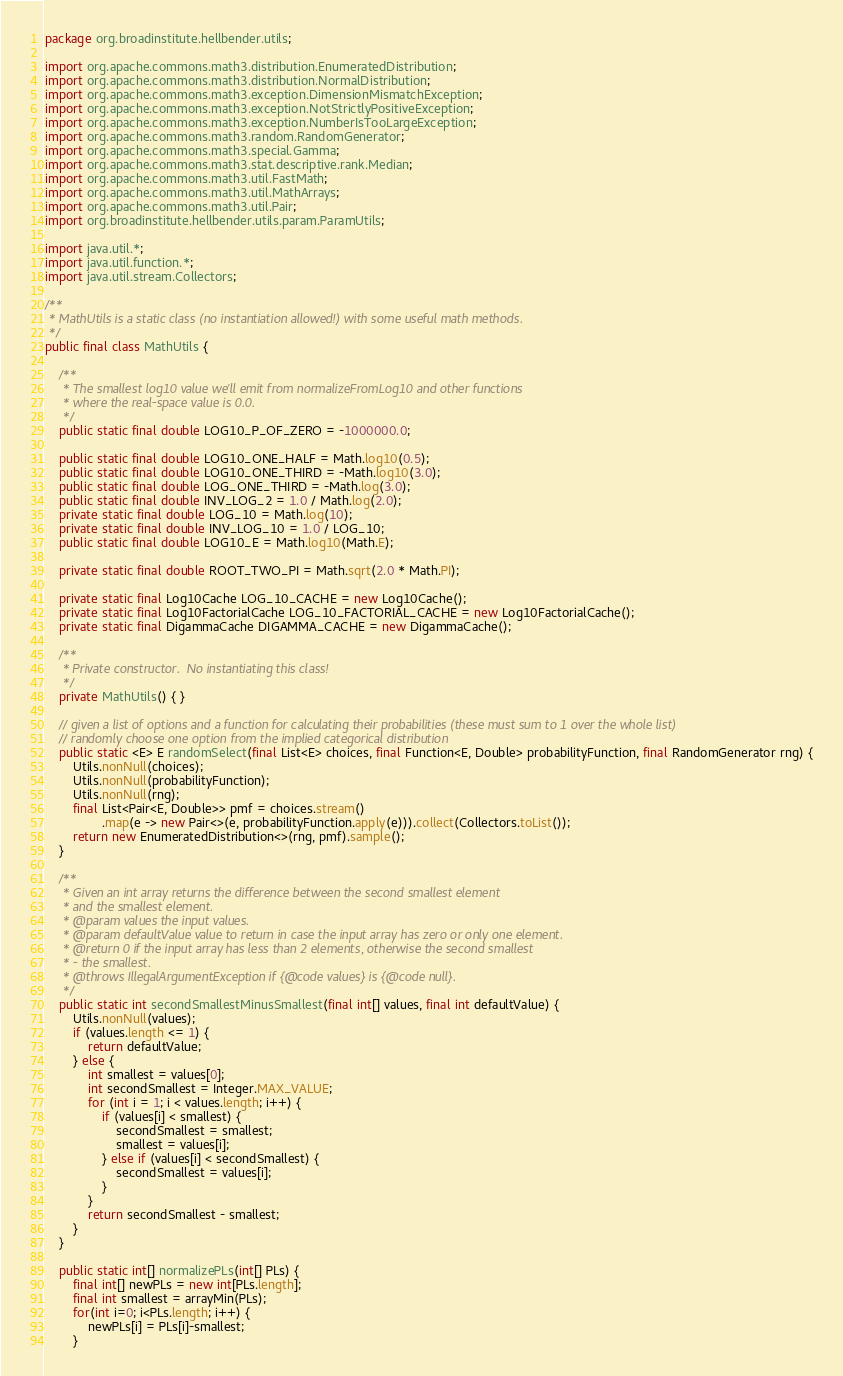<code> <loc_0><loc_0><loc_500><loc_500><_Java_>package org.broadinstitute.hellbender.utils;

import org.apache.commons.math3.distribution.EnumeratedDistribution;
import org.apache.commons.math3.distribution.NormalDistribution;
import org.apache.commons.math3.exception.DimensionMismatchException;
import org.apache.commons.math3.exception.NotStrictlyPositiveException;
import org.apache.commons.math3.exception.NumberIsTooLargeException;
import org.apache.commons.math3.random.RandomGenerator;
import org.apache.commons.math3.special.Gamma;
import org.apache.commons.math3.stat.descriptive.rank.Median;
import org.apache.commons.math3.util.FastMath;
import org.apache.commons.math3.util.MathArrays;
import org.apache.commons.math3.util.Pair;
import org.broadinstitute.hellbender.utils.param.ParamUtils;

import java.util.*;
import java.util.function.*;
import java.util.stream.Collectors;

/**
 * MathUtils is a static class (no instantiation allowed!) with some useful math methods.
 */
public final class MathUtils {

    /**
     * The smallest log10 value we'll emit from normalizeFromLog10 and other functions
     * where the real-space value is 0.0.
     */
    public static final double LOG10_P_OF_ZERO = -1000000.0;

    public static final double LOG10_ONE_HALF = Math.log10(0.5);
    public static final double LOG10_ONE_THIRD = -Math.log10(3.0);
    public static final double LOG_ONE_THIRD = -Math.log(3.0);
    public static final double INV_LOG_2 = 1.0 / Math.log(2.0);
    private static final double LOG_10 = Math.log(10);
    private static final double INV_LOG_10 = 1.0 / LOG_10;
    public static final double LOG10_E = Math.log10(Math.E);

    private static final double ROOT_TWO_PI = Math.sqrt(2.0 * Math.PI);

    private static final Log10Cache LOG_10_CACHE = new Log10Cache();
    private static final Log10FactorialCache LOG_10_FACTORIAL_CACHE = new Log10FactorialCache();
    private static final DigammaCache DIGAMMA_CACHE = new DigammaCache();

    /**
     * Private constructor.  No instantiating this class!
     */
    private MathUtils() { }

    // given a list of options and a function for calculating their probabilities (these must sum to 1 over the whole list)
    // randomly choose one option from the implied categorical distribution
    public static <E> E randomSelect(final List<E> choices, final Function<E, Double> probabilityFunction, final RandomGenerator rng) {
        Utils.nonNull(choices);
        Utils.nonNull(probabilityFunction);
        Utils.nonNull(rng);
        final List<Pair<E, Double>> pmf = choices.stream()
                .map(e -> new Pair<>(e, probabilityFunction.apply(e))).collect(Collectors.toList());
        return new EnumeratedDistribution<>(rng, pmf).sample();
    }

    /**
     * Given an int array returns the difference between the second smallest element
     * and the smallest element.
     * @param values the input values.
     * @param defaultValue value to return in case the input array has zero or only one element.
     * @return 0 if the input array has less than 2 elements, otherwise the second smallest
     * - the smallest.
     * @throws IllegalArgumentException if {@code values} is {@code null}.
     */
    public static int secondSmallestMinusSmallest(final int[] values, final int defaultValue) {
        Utils.nonNull(values);
        if (values.length <= 1) {
            return defaultValue;
        } else {
            int smallest = values[0];
            int secondSmallest = Integer.MAX_VALUE;
            for (int i = 1; i < values.length; i++) {
                if (values[i] < smallest) {
                    secondSmallest = smallest;
                    smallest = values[i];
                } else if (values[i] < secondSmallest) {
                    secondSmallest = values[i];
                }
            }
            return secondSmallest - smallest;
        }
    }

    public static int[] normalizePLs(int[] PLs) {
        final int[] newPLs = new int[PLs.length];
        final int smallest = arrayMin(PLs);
        for(int i=0; i<PLs.length; i++) {
            newPLs[i] = PLs[i]-smallest;
        }</code> 